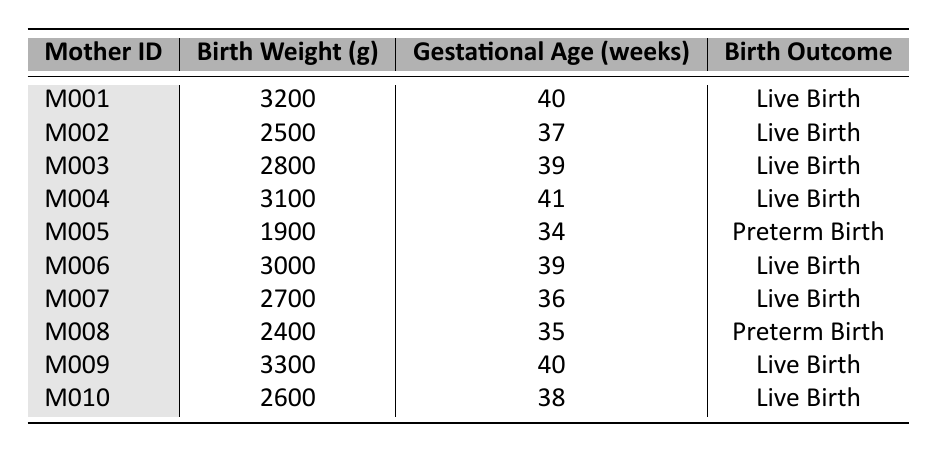What is the birth weight of mother M005? According to the table, mother M005 has a birth weight of 1900 grams.
Answer: 1900 grams What is the gestational age for mother M004? The table shows that mother M004 has a gestational age of 41 weeks.
Answer: 41 weeks How many mothers had a live birth? By counting the rows with "Live Birth" in the birth outcome column, we find there are 8 mothers with live births.
Answer: 8 mothers What is the average birth weight of the infants? Adding all birth weights: (3200 + 2500 + 2800 + 3100 + 1900 + 3000 + 2700 + 2400 + 3300 + 2600) =  30,000 grams. There are 10 infants, so the average birth weight is 30,000/10 = 3000 grams.
Answer: 3000 grams What is the percentage of preterm births in this data? There are 2 preterm births (M005 and M008) out of a total of 10 births. The percentage is (2/10) * 100 = 20%.
Answer: 20% Which mother had the lowest birth weight? Looking through the birth weights, mother M005 has the lowest at 1900 grams.
Answer: M005 Is there any mother who had a birth weight above 3300 grams? Scanning the table, no birth weight exceeds 3300 grams; therefore, the answer is no.
Answer: No How many weeks of gestational age did the baby from the mother with the highest birth weight have? The highest birth weight is 3300 grams from mother M009, who had a gestational age of 40 weeks.
Answer: 40 weeks What is the difference in birth weight between the heaviest and lightest infants? The heaviest infant weighs 3300 grams (M009) and the lightest weighs 1900 grams (M005). The difference is 3300 - 1900 = 1400 grams.
Answer: 1400 grams What is the most common birth outcome based on this data? By analyzing the outcomes, "Live Birth" occurs 8 times while "Preterm Birth" occurs 2 times, making "Live Birth" the most common outcome.
Answer: Live Birth 